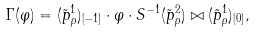Convert formula to latex. <formula><loc_0><loc_0><loc_500><loc_500>\Gamma ( \varphi ) = ( \tilde { p } ^ { 1 } _ { \rho } ) _ { [ - 1 ] } \cdot \varphi \cdot S ^ { - 1 } ( \tilde { p } ^ { 2 } _ { \rho } ) \bowtie ( \tilde { p } ^ { 1 } _ { \rho } ) _ { [ 0 ] } ,</formula> 